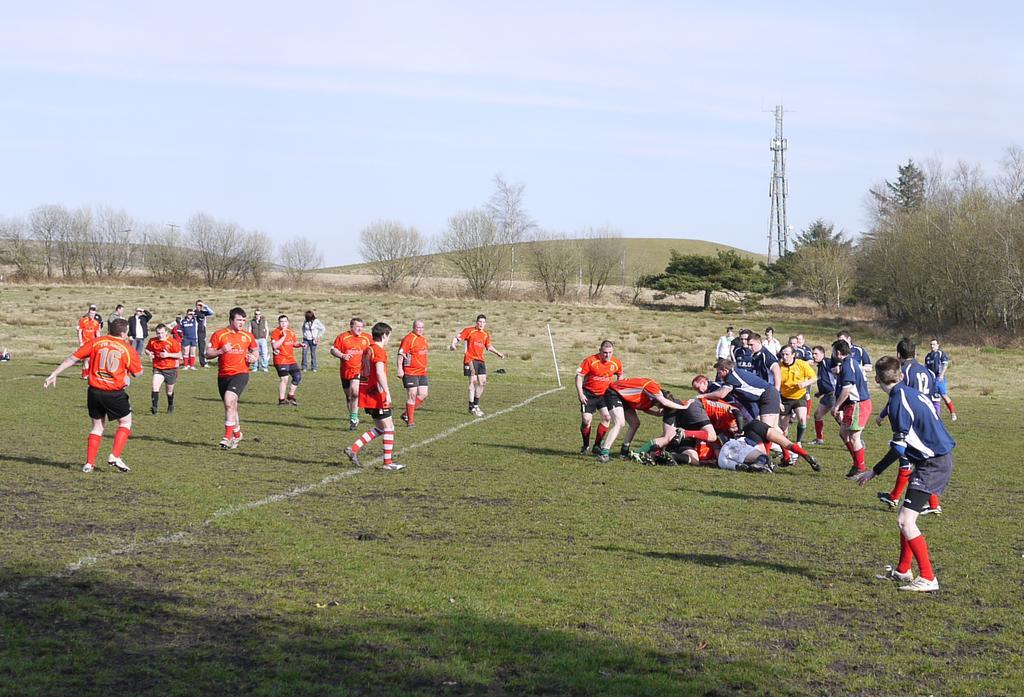Describe this image in one or two sentences. In this picture I can see there are some people standing here wearing a jersey´s and they are two teams here in the playground. 